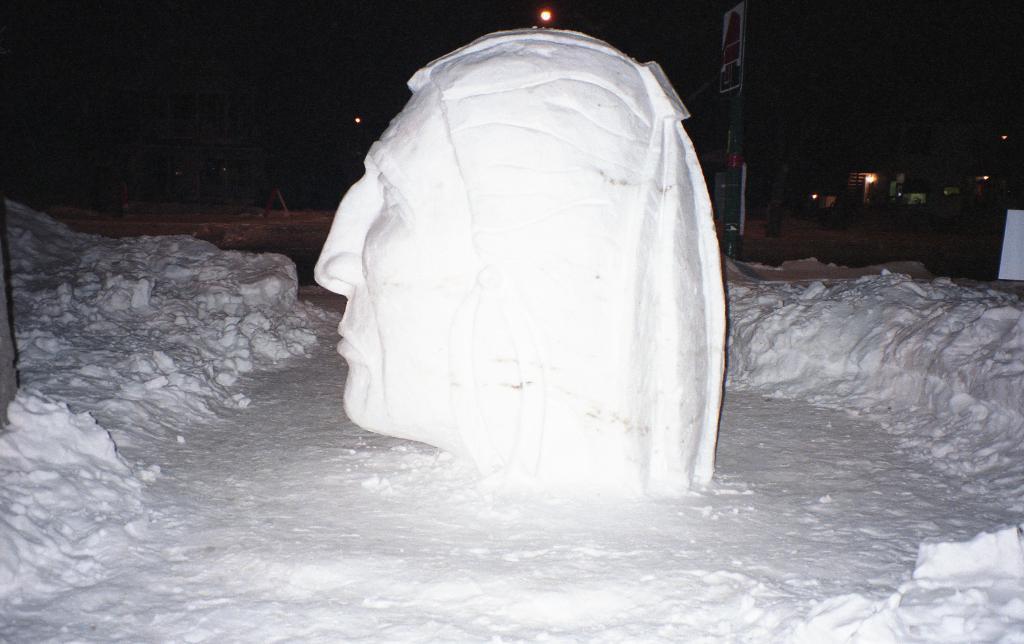Describe this image in one or two sentences. In this image I see a sculpture of a face which is of white in color and I see the snow around it and I see that it is dark in the background and I see few lights. 